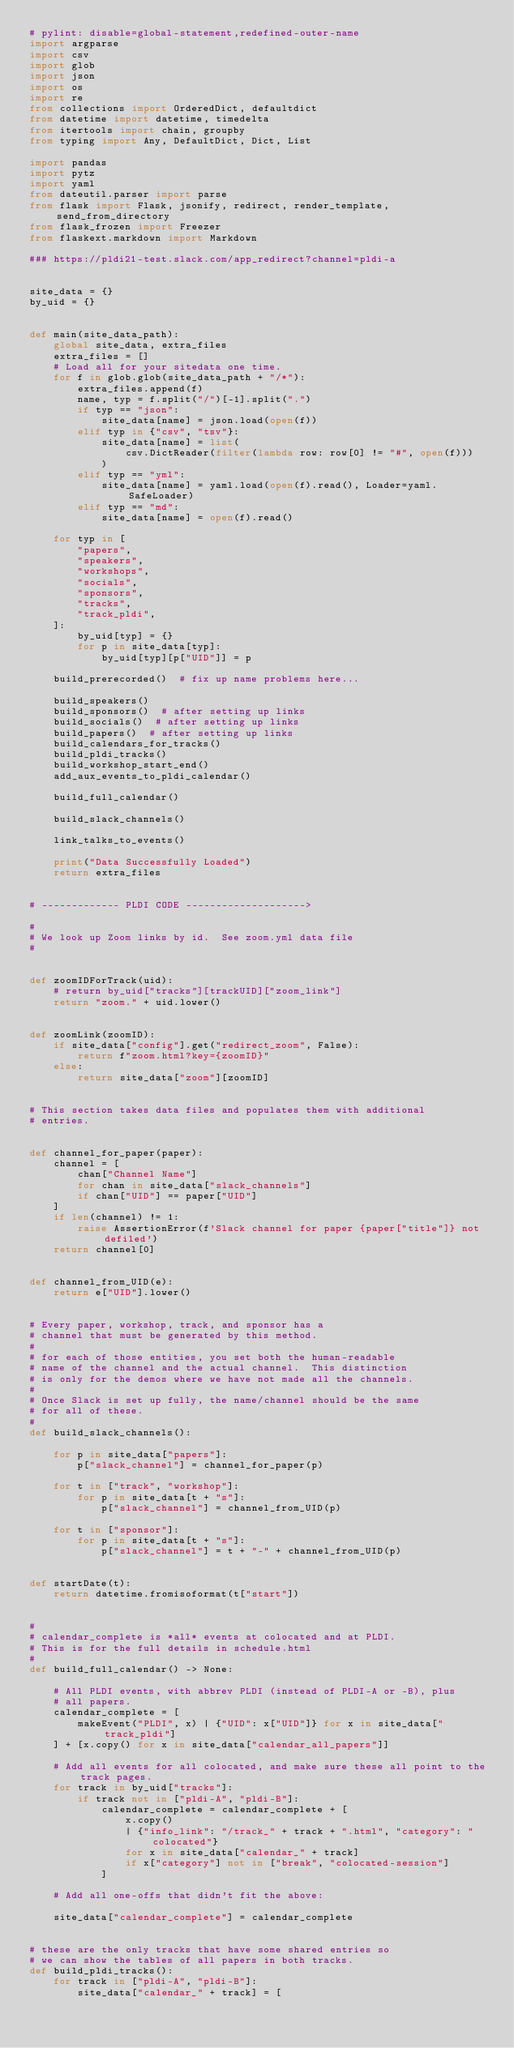Convert code to text. <code><loc_0><loc_0><loc_500><loc_500><_Python_># pylint: disable=global-statement,redefined-outer-name
import argparse
import csv
import glob
import json
import os
import re
from collections import OrderedDict, defaultdict
from datetime import datetime, timedelta
from itertools import chain, groupby
from typing import Any, DefaultDict, Dict, List

import pandas
import pytz
import yaml
from dateutil.parser import parse
from flask import Flask, jsonify, redirect, render_template, send_from_directory
from flask_frozen import Freezer
from flaskext.markdown import Markdown

### https://pldi21-test.slack.com/app_redirect?channel=pldi-a


site_data = {}
by_uid = {}


def main(site_data_path):
    global site_data, extra_files
    extra_files = []
    # Load all for your sitedata one time.
    for f in glob.glob(site_data_path + "/*"):
        extra_files.append(f)
        name, typ = f.split("/")[-1].split(".")
        if typ == "json":
            site_data[name] = json.load(open(f))
        elif typ in {"csv", "tsv"}:
            site_data[name] = list(
                csv.DictReader(filter(lambda row: row[0] != "#", open(f)))
            )
        elif typ == "yml":
            site_data[name] = yaml.load(open(f).read(), Loader=yaml.SafeLoader)
        elif typ == "md":
            site_data[name] = open(f).read()

    for typ in [
        "papers",
        "speakers",
        "workshops",
        "socials",
        "sponsors",
        "tracks",
        "track_pldi",
    ]:
        by_uid[typ] = {}
        for p in site_data[typ]:
            by_uid[typ][p["UID"]] = p

    build_prerecorded()  # fix up name problems here...

    build_speakers()
    build_sponsors()  # after setting up links
    build_socials()  # after setting up links
    build_papers()  # after setting up links
    build_calendars_for_tracks()
    build_pldi_tracks()
    build_workshop_start_end()
    add_aux_events_to_pldi_calendar()

    build_full_calendar()

    build_slack_channels()

    link_talks_to_events()

    print("Data Successfully Loaded")
    return extra_files


# ------------- PLDI CODE -------------------->

#
# We look up Zoom links by id.  See zoom.yml data file
#


def zoomIDForTrack(uid):
    # return by_uid["tracks"][trackUID]["zoom_link"]
    return "zoom." + uid.lower()


def zoomLink(zoomID):
    if site_data["config"].get("redirect_zoom", False):
        return f"zoom.html?key={zoomID}"
    else:
        return site_data["zoom"][zoomID]


# This section takes data files and populates them with additional
# entries.


def channel_for_paper(paper):
    channel = [
        chan["Channel Name"]
        for chan in site_data["slack_channels"]
        if chan["UID"] == paper["UID"]
    ]
    if len(channel) != 1:
        raise AssertionError(f'Slack channel for paper {paper["title"]} not defiled')
    return channel[0]


def channel_from_UID(e):
    return e["UID"].lower()


# Every paper, workshop, track, and sponsor has a
# channel that must be generated by this method.
#
# for each of those entities, you set both the human-readable
# name of the channel and the actual channel.  This distinction
# is only for the demos where we have not made all the channels.
#
# Once Slack is set up fully, the name/channel should be the same
# for all of these.
#
def build_slack_channels():

    for p in site_data["papers"]:
        p["slack_channel"] = channel_for_paper(p)

    for t in ["track", "workshop"]:
        for p in site_data[t + "s"]:
            p["slack_channel"] = channel_from_UID(p)

    for t in ["sponsor"]:
        for p in site_data[t + "s"]:
            p["slack_channel"] = t + "-" + channel_from_UID(p)


def startDate(t):
    return datetime.fromisoformat(t["start"])


#
# calendar_complete is *all* events at colocated and at PLDI.
# This is for the full details in schedule.html
#
def build_full_calendar() -> None:

    # All PLDI events, with abbrev PLDI (instead of PLDI-A or -B), plus
    # all papers.
    calendar_complete = [
        makeEvent("PLDI", x) | {"UID": x["UID"]} for x in site_data["track_pldi"]
    ] + [x.copy() for x in site_data["calendar_all_papers"]]

    # Add all events for all colocated, and make sure these all point to the track pages.
    for track in by_uid["tracks"]:
        if track not in ["pldi-A", "pldi-B"]:
            calendar_complete = calendar_complete + [
                x.copy()
                | {"info_link": "/track_" + track + ".html", "category": "colocated"}
                for x in site_data["calendar_" + track]
                if x["category"] not in ["break", "colocated-session"]
            ]

    # Add all one-offs that didn't fit the above:

    site_data["calendar_complete"] = calendar_complete


# these are the only tracks that have some shared entries so
# we can show the tables of all papers in both tracks.
def build_pldi_tracks():
    for track in ["pldi-A", "pldi-B"]:
        site_data["calendar_" + track] = [</code> 